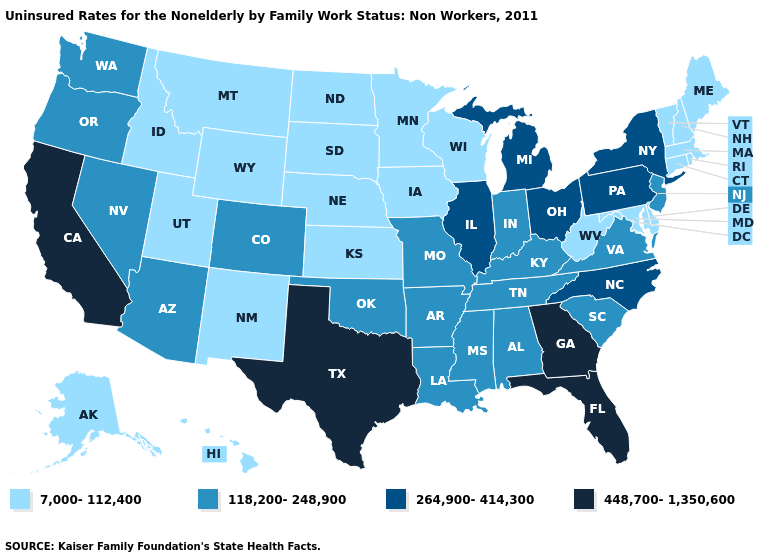What is the lowest value in the West?
Quick response, please. 7,000-112,400. Does Texas have the highest value in the USA?
Quick response, please. Yes. Name the states that have a value in the range 448,700-1,350,600?
Quick response, please. California, Florida, Georgia, Texas. Among the states that border Illinois , does Wisconsin have the lowest value?
Concise answer only. Yes. What is the lowest value in the West?
Short answer required. 7,000-112,400. Does Iowa have the lowest value in the USA?
Concise answer only. Yes. What is the value of New Jersey?
Concise answer only. 118,200-248,900. What is the lowest value in states that border Nevada?
Answer briefly. 7,000-112,400. What is the lowest value in states that border Ohio?
Answer briefly. 7,000-112,400. What is the value of Michigan?
Be succinct. 264,900-414,300. What is the lowest value in states that border Connecticut?
Be succinct. 7,000-112,400. What is the highest value in states that border Mississippi?
Give a very brief answer. 118,200-248,900. Does Virginia have the highest value in the USA?
Concise answer only. No. Which states have the highest value in the USA?
Quick response, please. California, Florida, Georgia, Texas. 